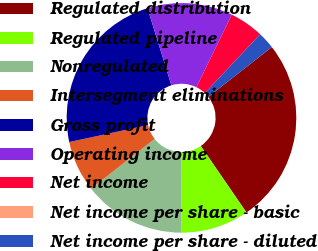Convert chart to OTSL. <chart><loc_0><loc_0><loc_500><loc_500><pie_chart><fcel>Regulated distribution<fcel>Regulated pipeline<fcel>Nonregulated<fcel>Intersegment eliminations<fcel>Gross profit<fcel>Operating income<fcel>Net income<fcel>Net income per share - basic<fcel>Net income per share - diluted<nl><fcel>26.0%<fcel>9.6%<fcel>14.4%<fcel>7.2%<fcel>23.6%<fcel>12.0%<fcel>4.8%<fcel>0.0%<fcel>2.4%<nl></chart> 